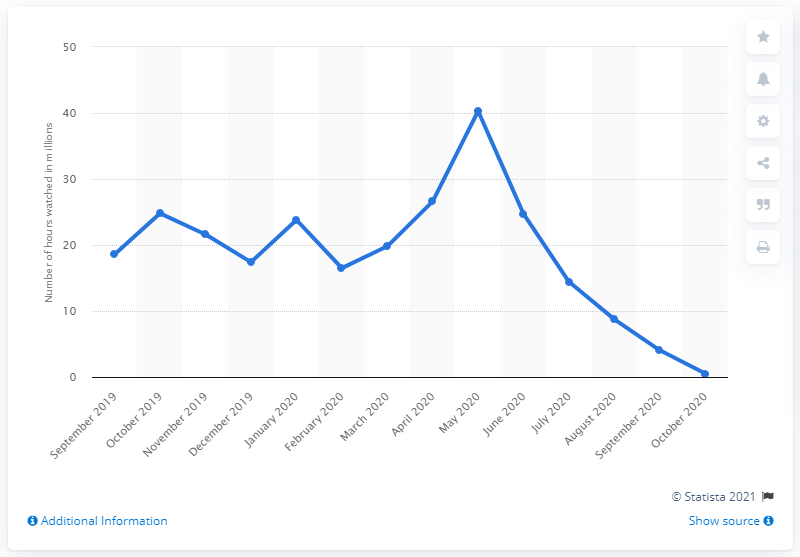Draw attention to some important aspects in this diagram. In September 2020, the amount of hours watched on Twitch was 4.04. On September 2019, FIFA 20 was released. 